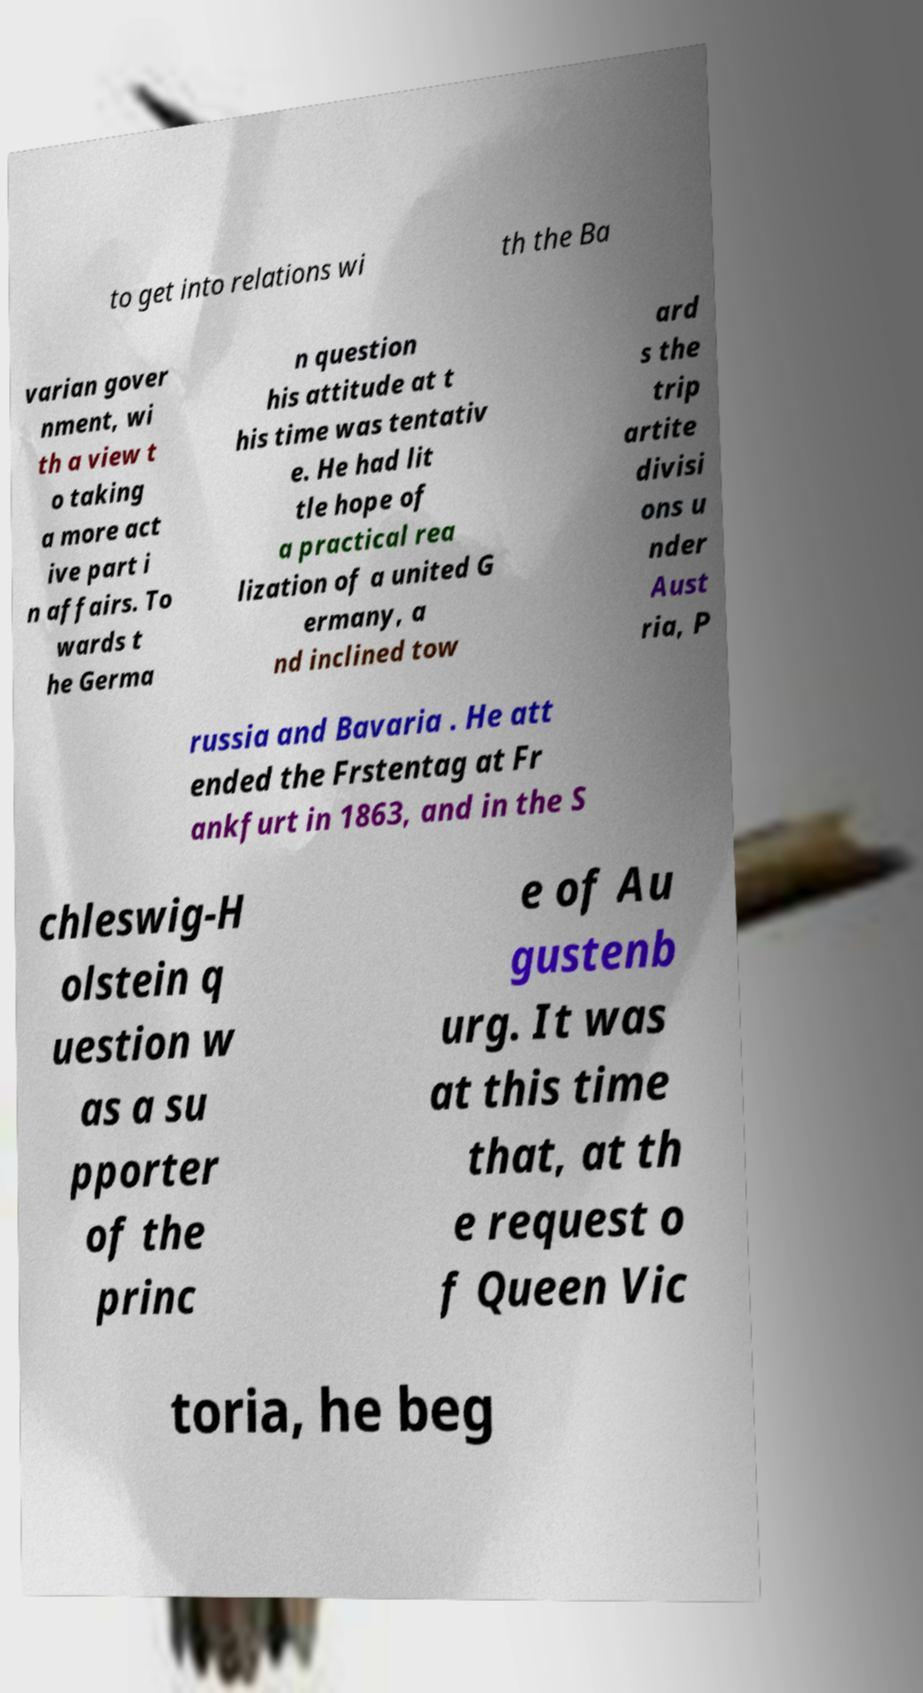For documentation purposes, I need the text within this image transcribed. Could you provide that? to get into relations wi th the Ba varian gover nment, wi th a view t o taking a more act ive part i n affairs. To wards t he Germa n question his attitude at t his time was tentativ e. He had lit tle hope of a practical rea lization of a united G ermany, a nd inclined tow ard s the trip artite divisi ons u nder Aust ria, P russia and Bavaria . He att ended the Frstentag at Fr ankfurt in 1863, and in the S chleswig-H olstein q uestion w as a su pporter of the princ e of Au gustenb urg. It was at this time that, at th e request o f Queen Vic toria, he beg 